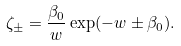<formula> <loc_0><loc_0><loc_500><loc_500>\zeta _ { \pm } = \frac { \beta _ { 0 } } { w } \exp ( - w \pm \beta _ { 0 } ) .</formula> 